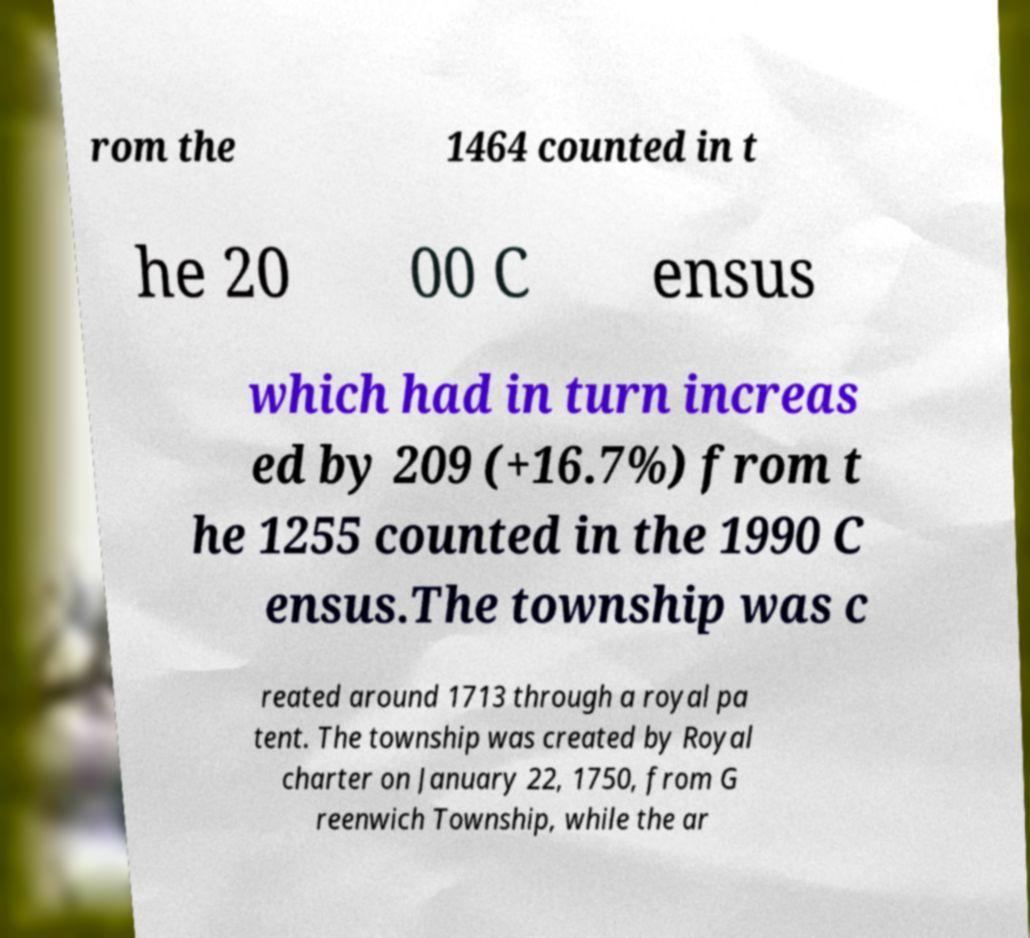I need the written content from this picture converted into text. Can you do that? rom the 1464 counted in t he 20 00 C ensus which had in turn increas ed by 209 (+16.7%) from t he 1255 counted in the 1990 C ensus.The township was c reated around 1713 through a royal pa tent. The township was created by Royal charter on January 22, 1750, from G reenwich Township, while the ar 